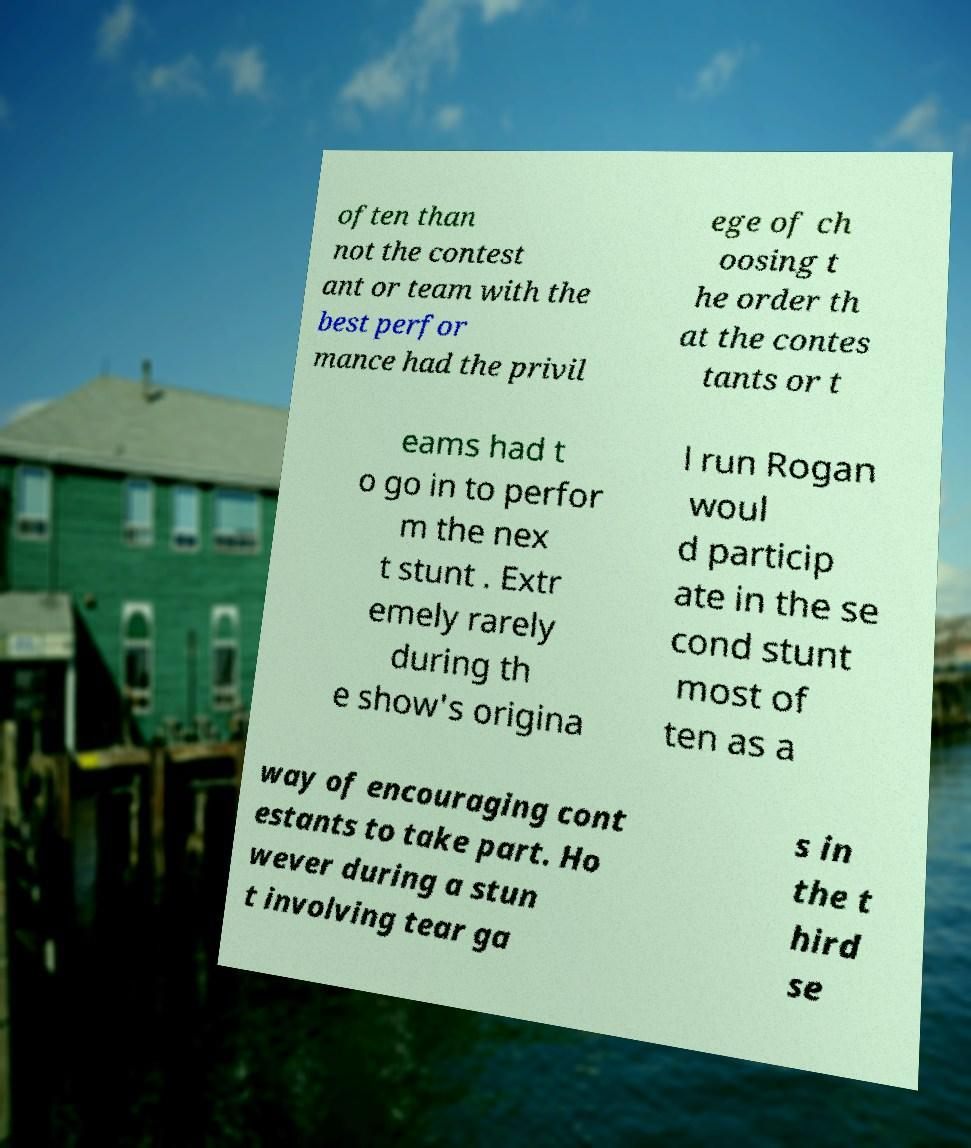What messages or text are displayed in this image? I need them in a readable, typed format. often than not the contest ant or team with the best perfor mance had the privil ege of ch oosing t he order th at the contes tants or t eams had t o go in to perfor m the nex t stunt . Extr emely rarely during th e show's origina l run Rogan woul d particip ate in the se cond stunt most of ten as a way of encouraging cont estants to take part. Ho wever during a stun t involving tear ga s in the t hird se 